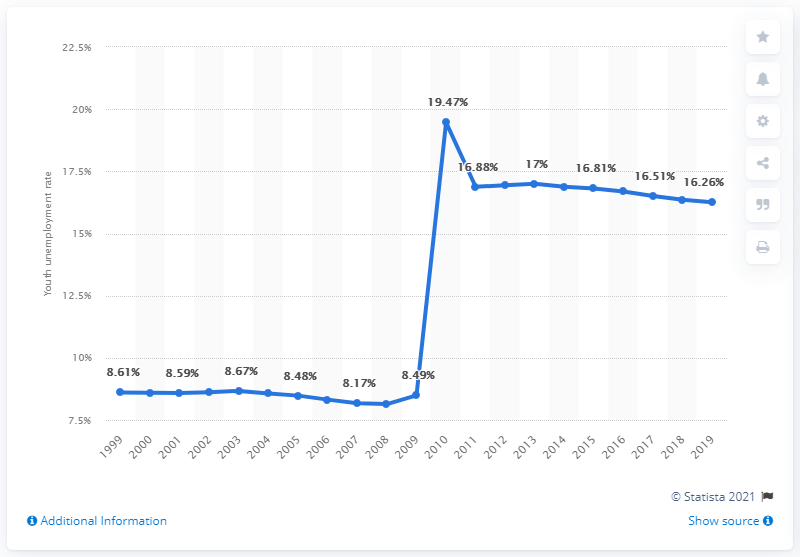Specify some key components in this picture. In 2019, the youth unemployment rate in Angola was 16.26%. 